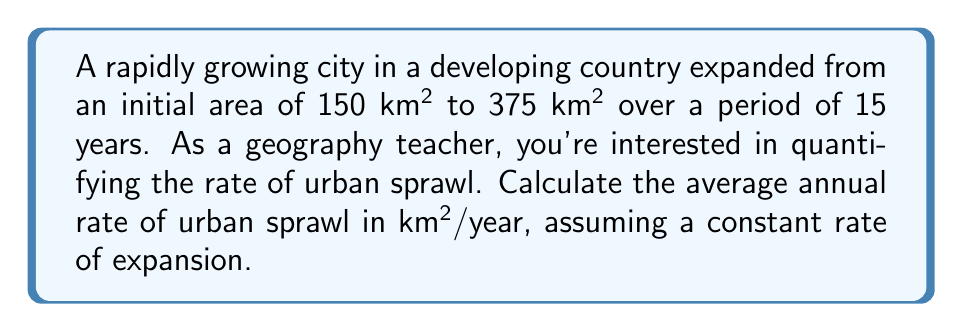Can you answer this question? To solve this problem, we'll follow these steps:

1) Define the variables:
   $A_i$ = initial area = 150 km²
   $A_f$ = final area = 375 km²
   $t$ = time period = 15 years

2) Calculate the total change in area:
   $\Delta A = A_f - A_i = 375 - 150 = 225$ km²

3) Calculate the average annual rate of urban sprawl:
   Rate = $\frac{\text{Change in area}}{\text{Time period}}$

   $\text{Rate} = \frac{\Delta A}{t} = \frac{225 \text{ km²}}{15 \text{ years}}$

4) Simplify the fraction:
   $\text{Rate} = 15 \text{ km²/year}$

This rate indicates that, on average, the city expanded by 15 square kilometers each year over the 15-year period. As a geography teacher, you could use this to discuss how rapid urbanization affects the surrounding environment, infrastructure needs, and socio-economic patterns in developing countries.
Answer: 15 km²/year 